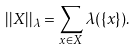Convert formula to latex. <formula><loc_0><loc_0><loc_500><loc_500>| | X | | _ { \lambda } = \sum _ { x \in X } \lambda ( \{ x \} ) .</formula> 